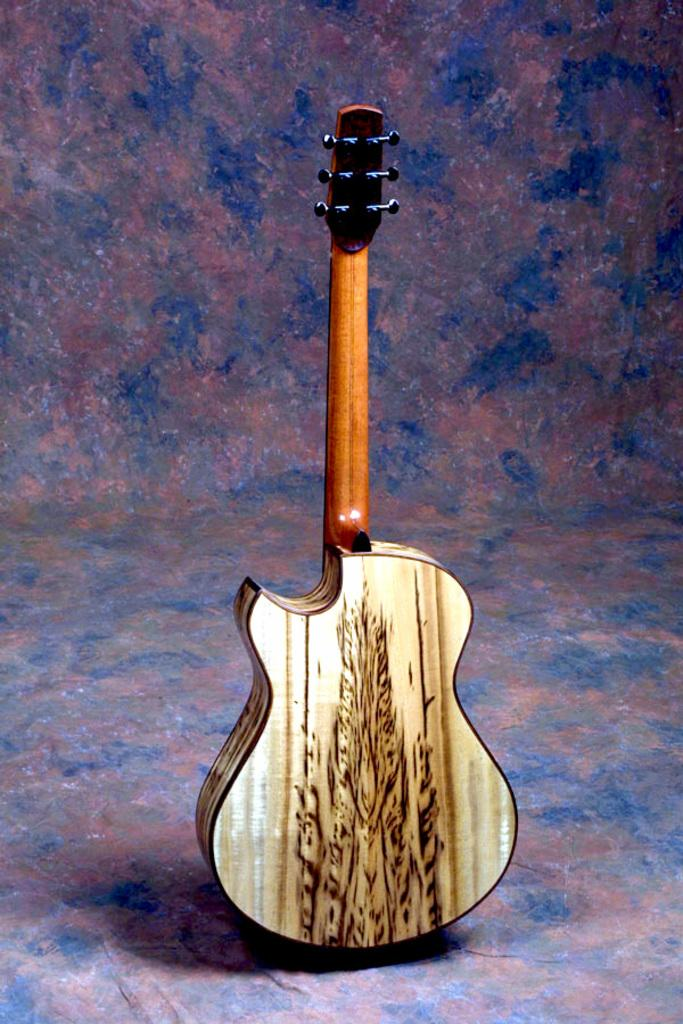What musical instrument is present in the image? There is a guitar on a surface in the image. Can you describe the position of the guitar in the image? The guitar is on a surface in the image. What might the guitar be used for in the image? The guitar is likely used for playing music, as it is a musical instrument. What type of impulse can be seen traveling through the guitar strings in the image? There is no impulse traveling through the guitar strings in the image, as it is a still image and not a video or animation. 